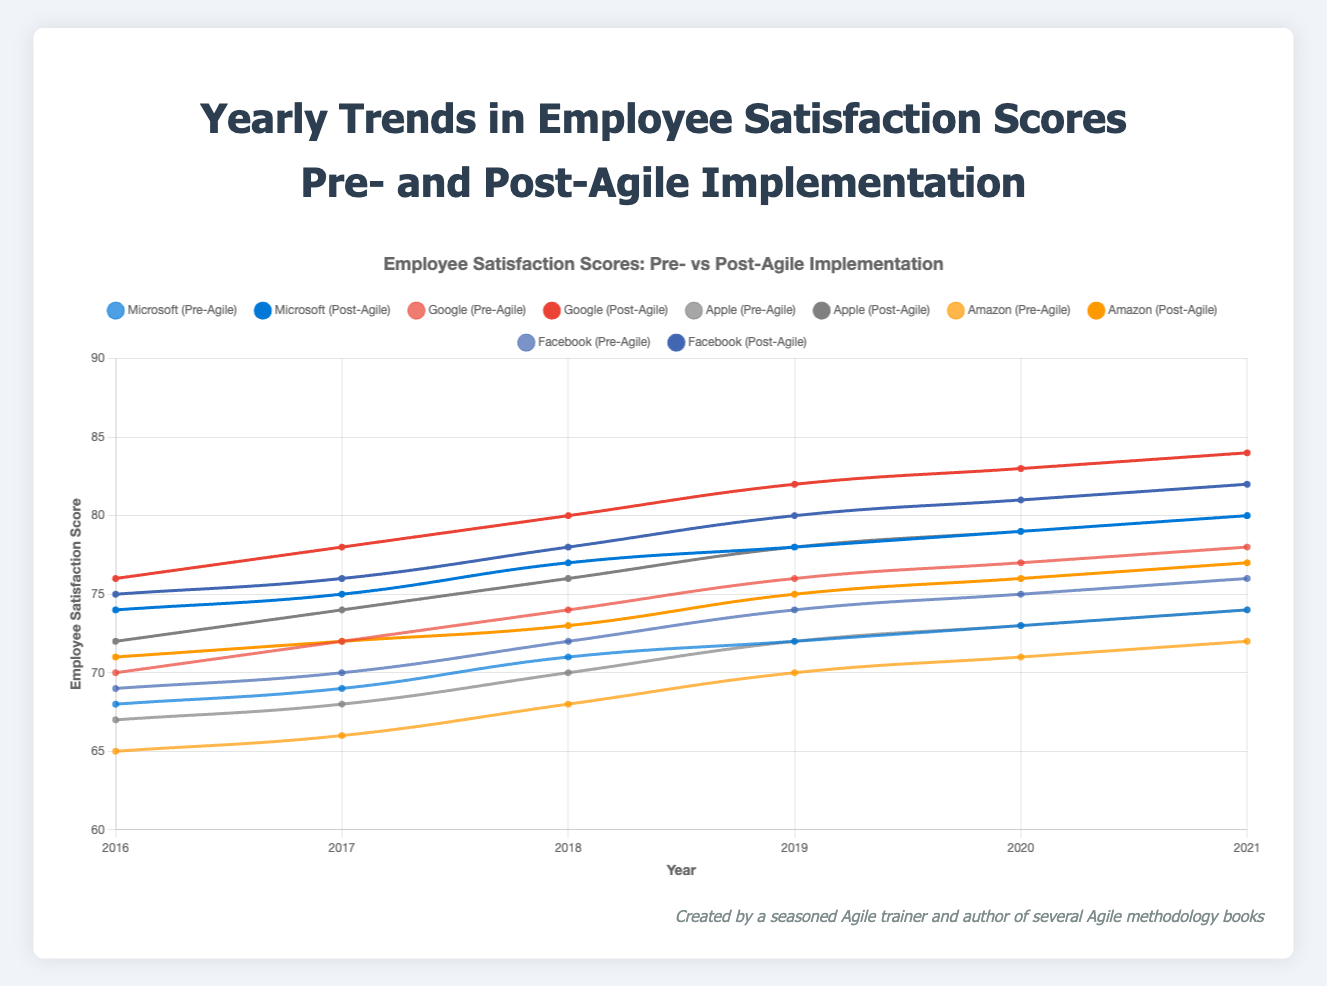For Facebook, what is the average post-Agile satisfaction score from 2016 to 2021? Post-Agile scores for Facebook from 2016 to 2021 are 75, 76, 78, 80, 81, and 82. Sum these scores (75 + 76 + 78 + 80 + 81 + 82 = 472) and then divide by the number of years (472 / 6 = 78.67).
Answer: 78.67 